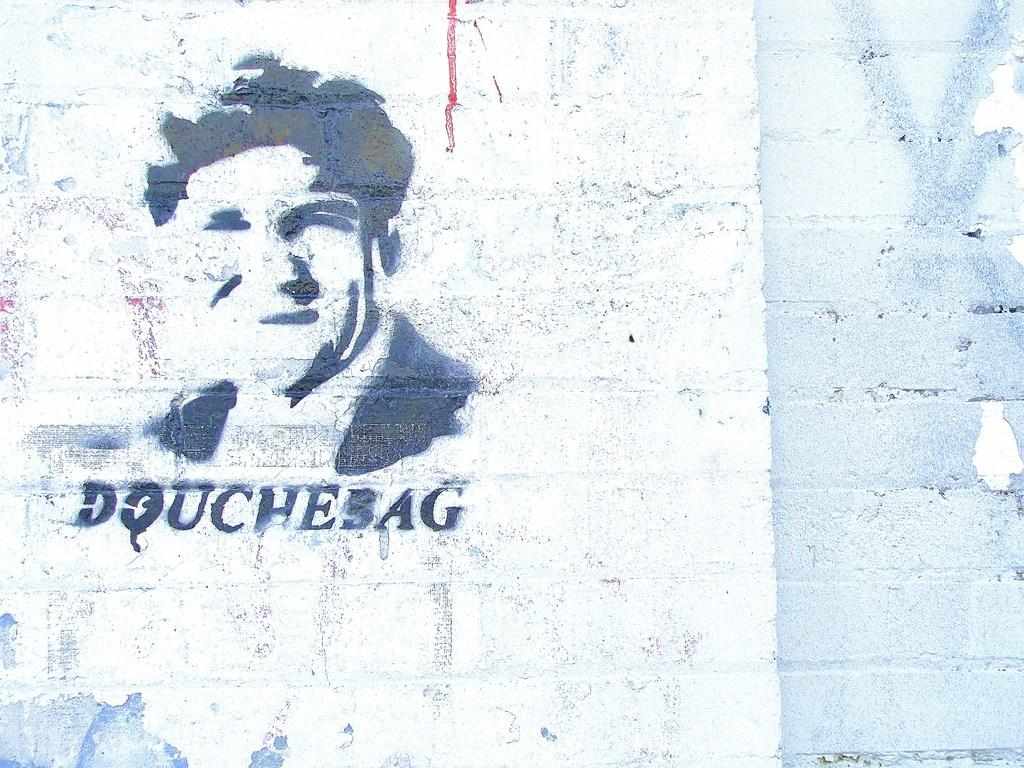What is the main color of the object in the image? The main color of the object in the image is white. What is depicted on the white object? The white object has a painting of a man on it. Is there any text associated with the painting? Yes, there is text written below the painting. How does the fog affect the power of the man in the image? There is no fog present in the image, and therefore its effect on the man cannot be determined. 